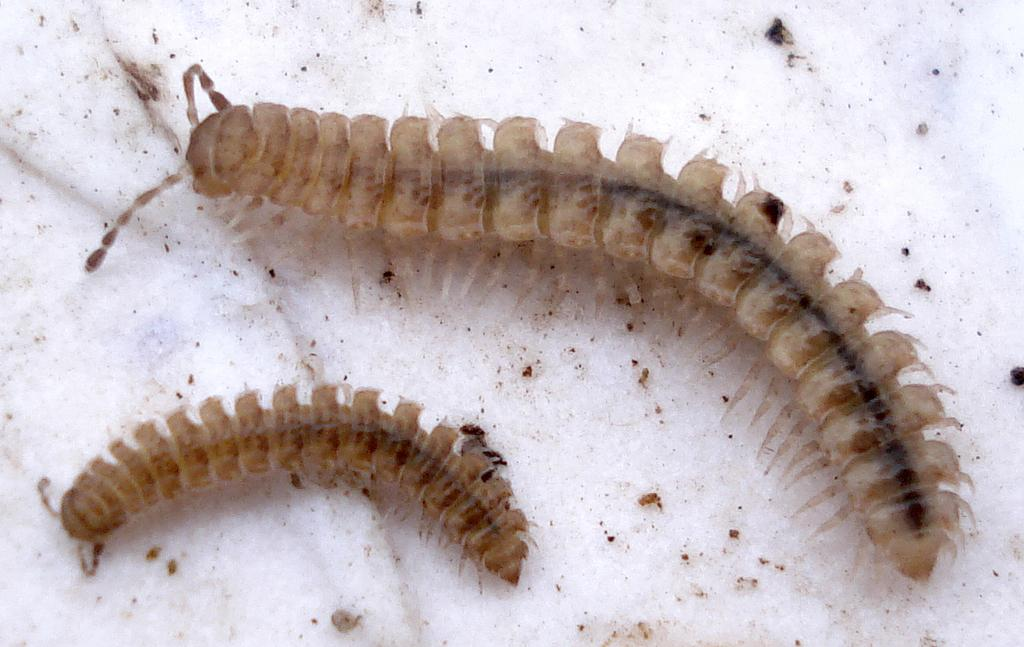What type of creatures can be seen in the image? There are two insects visible in the image. Where are the insects located in the image? The insects are on the floor. What type of berries are the insects eating in the image? There are no berries present in the image, and therefore no such activity can be observed. How many sisters do the insects have in the image? There is no mention of sisters in the image, as it features two insects on the floor. 